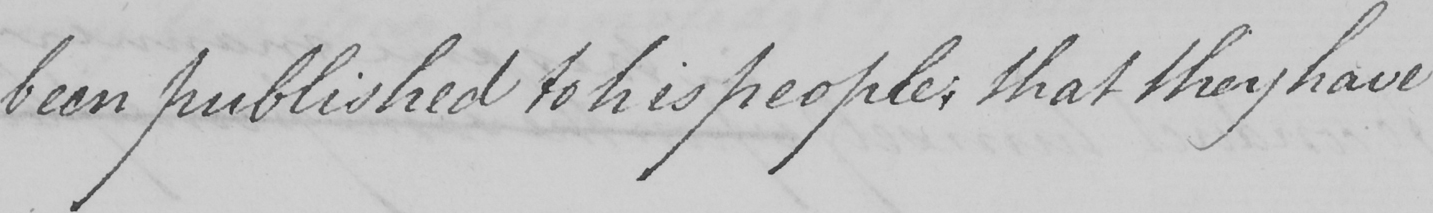Can you tell me what this handwritten text says? been published to his people , that they have 